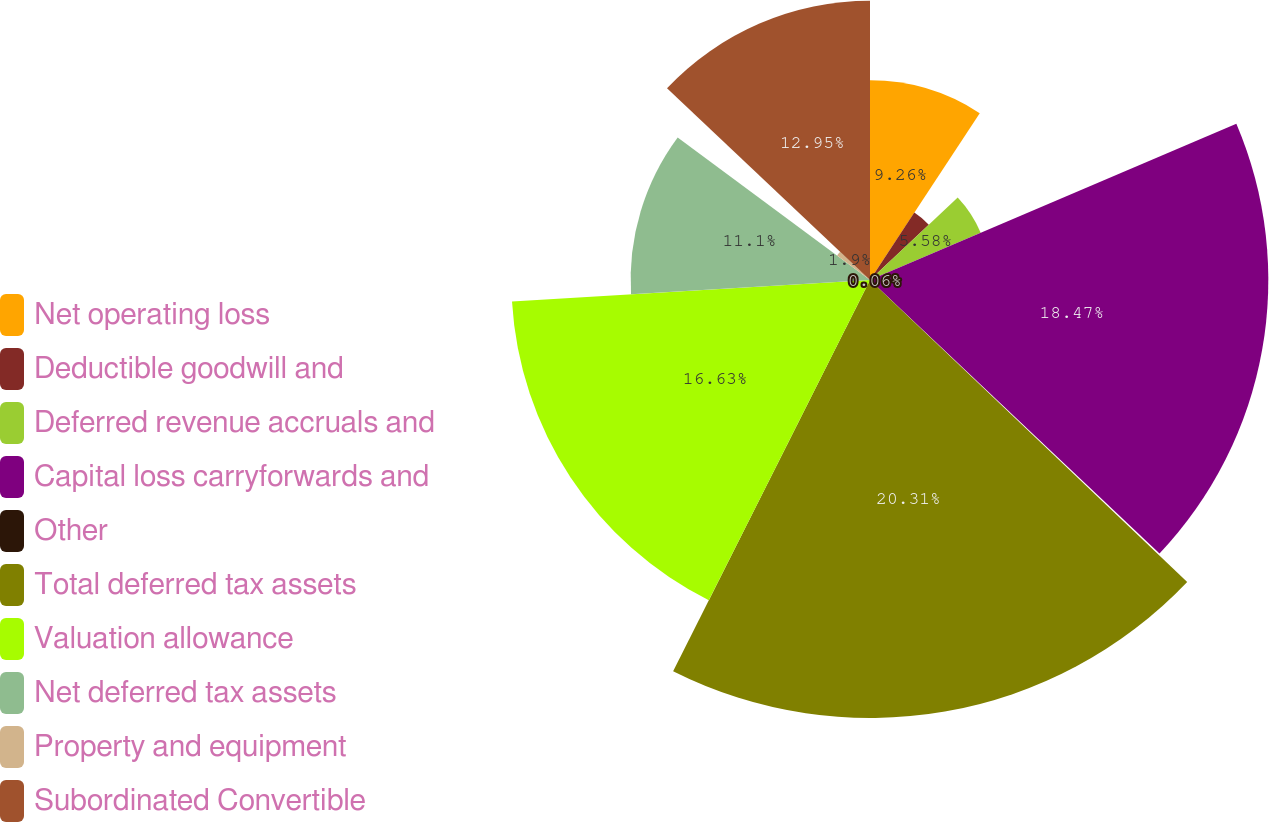Convert chart. <chart><loc_0><loc_0><loc_500><loc_500><pie_chart><fcel>Net operating loss<fcel>Deductible goodwill and<fcel>Deferred revenue accruals and<fcel>Capital loss carryforwards and<fcel>Other<fcel>Total deferred tax assets<fcel>Valuation allowance<fcel>Net deferred tax assets<fcel>Property and equipment<fcel>Subordinated Convertible<nl><fcel>9.26%<fcel>3.74%<fcel>5.58%<fcel>18.47%<fcel>0.06%<fcel>20.31%<fcel>16.63%<fcel>11.1%<fcel>1.9%<fcel>12.95%<nl></chart> 